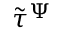<formula> <loc_0><loc_0><loc_500><loc_500>\tilde { \tau } ^ { \Psi }</formula> 